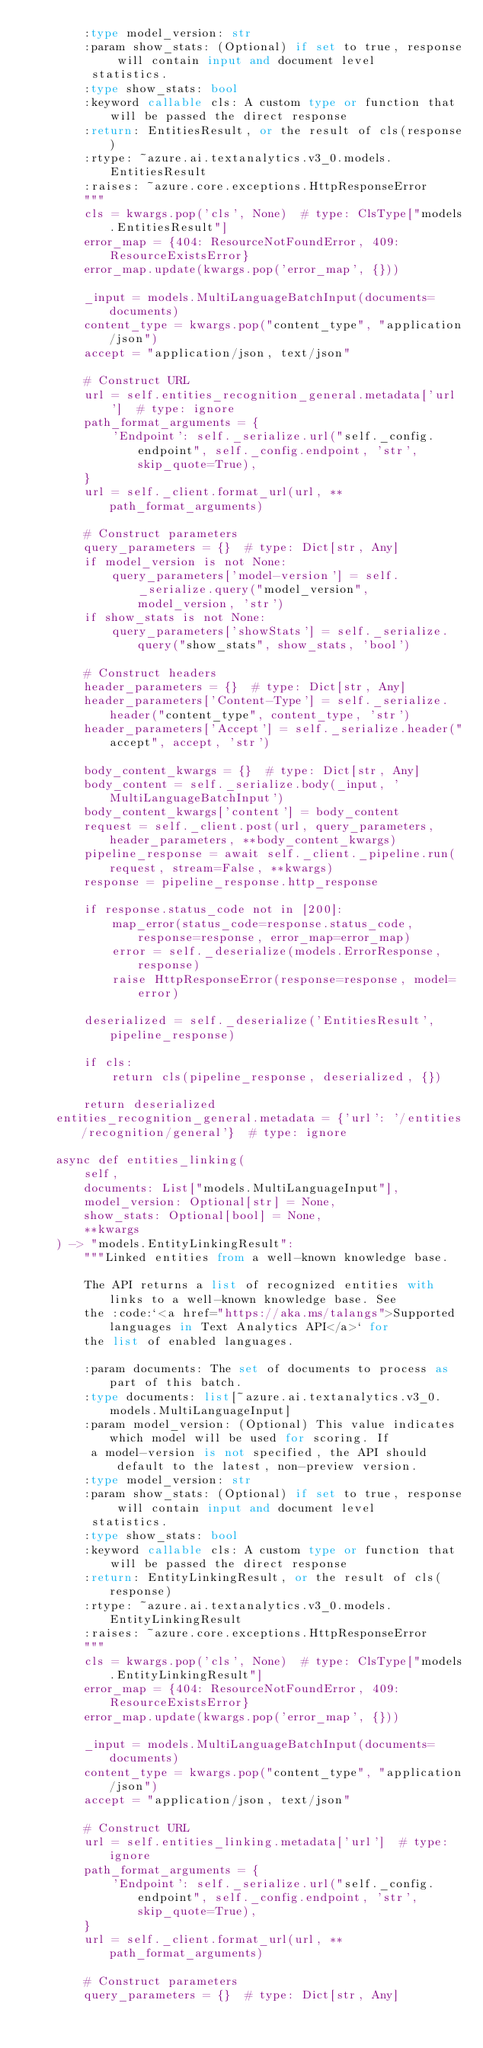Convert code to text. <code><loc_0><loc_0><loc_500><loc_500><_Python_>        :type model_version: str
        :param show_stats: (Optional) if set to true, response will contain input and document level
         statistics.
        :type show_stats: bool
        :keyword callable cls: A custom type or function that will be passed the direct response
        :return: EntitiesResult, or the result of cls(response)
        :rtype: ~azure.ai.textanalytics.v3_0.models.EntitiesResult
        :raises: ~azure.core.exceptions.HttpResponseError
        """
        cls = kwargs.pop('cls', None)  # type: ClsType["models.EntitiesResult"]
        error_map = {404: ResourceNotFoundError, 409: ResourceExistsError}
        error_map.update(kwargs.pop('error_map', {}))

        _input = models.MultiLanguageBatchInput(documents=documents)
        content_type = kwargs.pop("content_type", "application/json")
        accept = "application/json, text/json"

        # Construct URL
        url = self.entities_recognition_general.metadata['url']  # type: ignore
        path_format_arguments = {
            'Endpoint': self._serialize.url("self._config.endpoint", self._config.endpoint, 'str', skip_quote=True),
        }
        url = self._client.format_url(url, **path_format_arguments)

        # Construct parameters
        query_parameters = {}  # type: Dict[str, Any]
        if model_version is not None:
            query_parameters['model-version'] = self._serialize.query("model_version", model_version, 'str')
        if show_stats is not None:
            query_parameters['showStats'] = self._serialize.query("show_stats", show_stats, 'bool')

        # Construct headers
        header_parameters = {}  # type: Dict[str, Any]
        header_parameters['Content-Type'] = self._serialize.header("content_type", content_type, 'str')
        header_parameters['Accept'] = self._serialize.header("accept", accept, 'str')

        body_content_kwargs = {}  # type: Dict[str, Any]
        body_content = self._serialize.body(_input, 'MultiLanguageBatchInput')
        body_content_kwargs['content'] = body_content
        request = self._client.post(url, query_parameters, header_parameters, **body_content_kwargs)
        pipeline_response = await self._client._pipeline.run(request, stream=False, **kwargs)
        response = pipeline_response.http_response

        if response.status_code not in [200]:
            map_error(status_code=response.status_code, response=response, error_map=error_map)
            error = self._deserialize(models.ErrorResponse, response)
            raise HttpResponseError(response=response, model=error)

        deserialized = self._deserialize('EntitiesResult', pipeline_response)

        if cls:
            return cls(pipeline_response, deserialized, {})

        return deserialized
    entities_recognition_general.metadata = {'url': '/entities/recognition/general'}  # type: ignore

    async def entities_linking(
        self,
        documents: List["models.MultiLanguageInput"],
        model_version: Optional[str] = None,
        show_stats: Optional[bool] = None,
        **kwargs
    ) -> "models.EntityLinkingResult":
        """Linked entities from a well-known knowledge base.

        The API returns a list of recognized entities with links to a well-known knowledge base. See
        the :code:`<a href="https://aka.ms/talangs">Supported languages in Text Analytics API</a>` for
        the list of enabled languages.

        :param documents: The set of documents to process as part of this batch.
        :type documents: list[~azure.ai.textanalytics.v3_0.models.MultiLanguageInput]
        :param model_version: (Optional) This value indicates which model will be used for scoring. If
         a model-version is not specified, the API should default to the latest, non-preview version.
        :type model_version: str
        :param show_stats: (Optional) if set to true, response will contain input and document level
         statistics.
        :type show_stats: bool
        :keyword callable cls: A custom type or function that will be passed the direct response
        :return: EntityLinkingResult, or the result of cls(response)
        :rtype: ~azure.ai.textanalytics.v3_0.models.EntityLinkingResult
        :raises: ~azure.core.exceptions.HttpResponseError
        """
        cls = kwargs.pop('cls', None)  # type: ClsType["models.EntityLinkingResult"]
        error_map = {404: ResourceNotFoundError, 409: ResourceExistsError}
        error_map.update(kwargs.pop('error_map', {}))

        _input = models.MultiLanguageBatchInput(documents=documents)
        content_type = kwargs.pop("content_type", "application/json")
        accept = "application/json, text/json"

        # Construct URL
        url = self.entities_linking.metadata['url']  # type: ignore
        path_format_arguments = {
            'Endpoint': self._serialize.url("self._config.endpoint", self._config.endpoint, 'str', skip_quote=True),
        }
        url = self._client.format_url(url, **path_format_arguments)

        # Construct parameters
        query_parameters = {}  # type: Dict[str, Any]</code> 